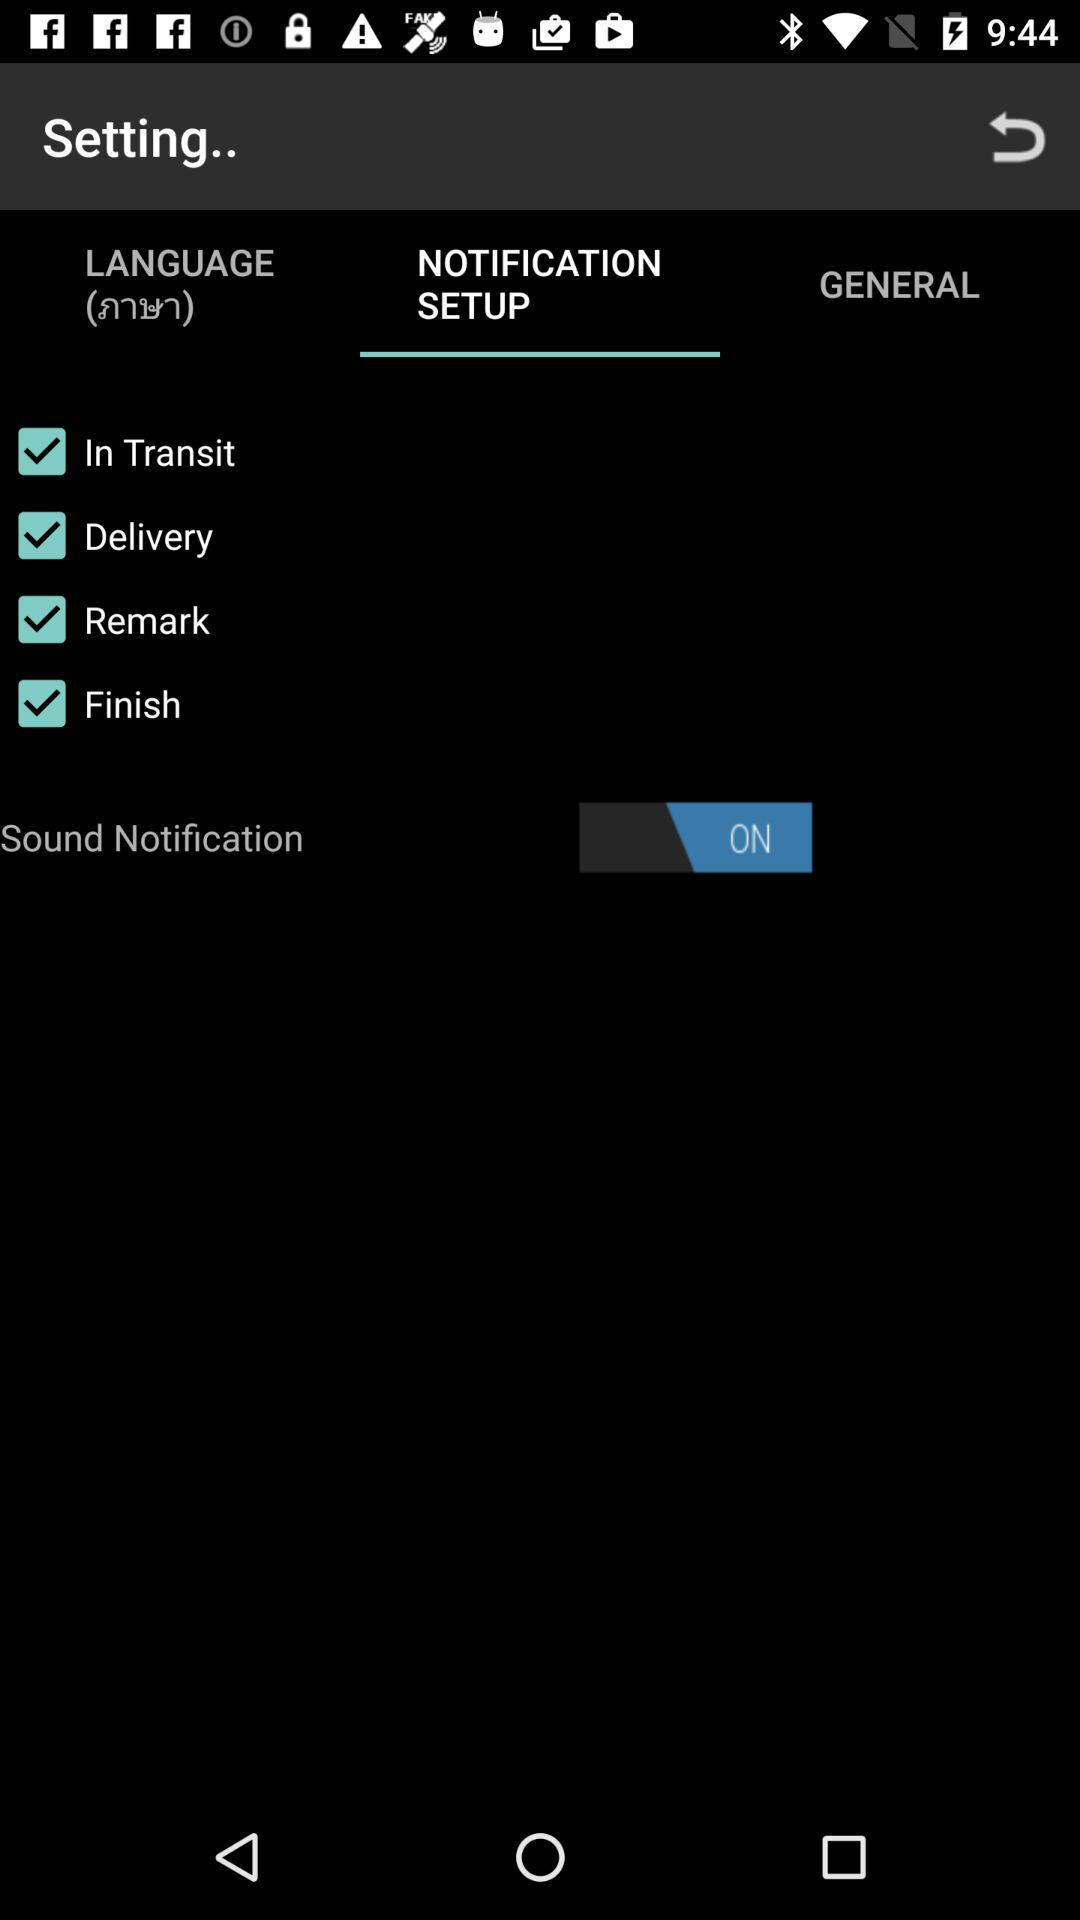What's the selected tab? The selected tab is "NOTIFICATION SETUP". 